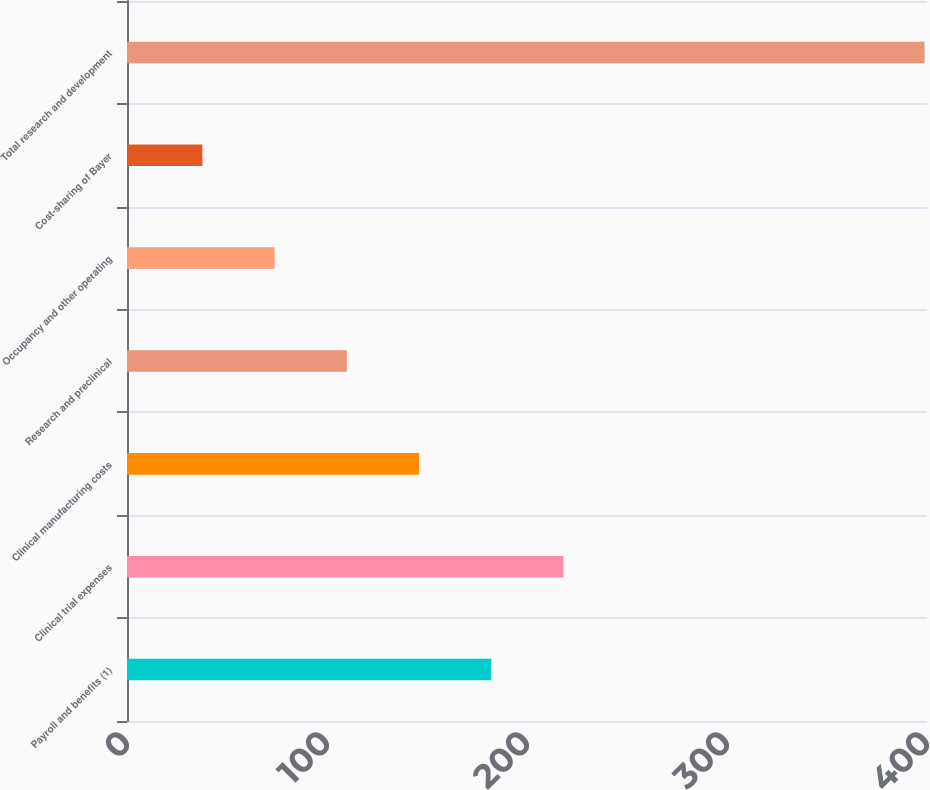Convert chart to OTSL. <chart><loc_0><loc_0><loc_500><loc_500><bar_chart><fcel>Payroll and benefits (1)<fcel>Clinical trial expenses<fcel>Clinical manufacturing costs<fcel>Research and preclinical<fcel>Occupancy and other operating<fcel>Cost-sharing of Bayer<fcel>Total research and development<nl><fcel>182.14<fcel>218.25<fcel>146.03<fcel>109.92<fcel>73.81<fcel>37.7<fcel>398.8<nl></chart> 